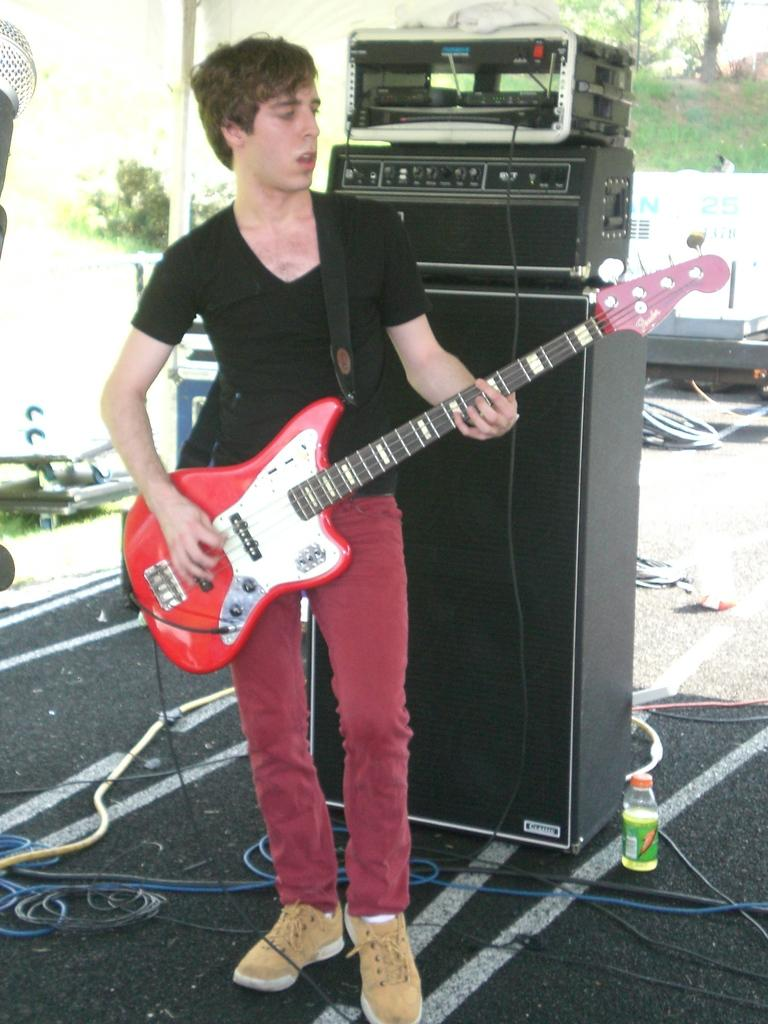What is the man in the image holding? The man is holding a guitar in the image. What can be seen in the background of the image? There are wires, a bottle, and a piece of equipment in the background of the image. How many seeds can be seen on the guitar in the image? There are no seeds visible on the guitar in the image, as it is a musical instrument and not a plant. 